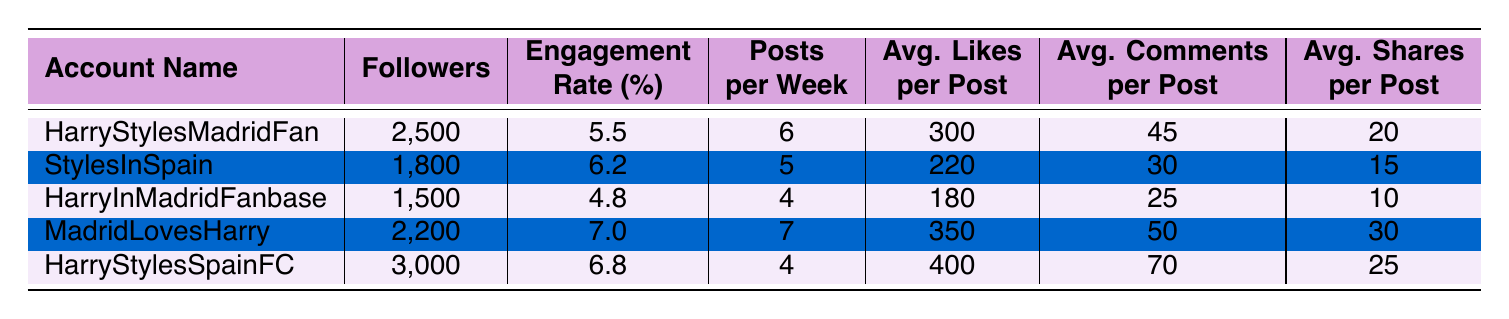What is the account with the highest followers? By comparing the followers column for all accounts, "HarryStylesSpainFC" has 3,000 followers, which is the highest among the listed accounts.
Answer: HarryStylesSpainFC What is the average engagement rate of the fan accounts? We calculate the average engagement rate by summing all engagement rates: (5.5 + 6.2 + 4.8 + 7.0 + 6.8) = 30.3. Then, divide by the number of accounts: 30.3 / 5 = 6.06.
Answer: 6.06 Does "MadridLovesHarry" have more average likes per post than "StylesInSpain"? "MadridLovesHarry" has 350 average likes per post while "StylesInSpain" has 220. Since 350 is greater than 220, the statement is true.
Answer: Yes Which account has the most shares per post? Reviewing the shares per post column, "MadridLovesHarry" has 30 shares per post, which is more than any other account.
Answer: MadridLovesHarry If we combine the followers of "HarryStylesMadridFan" and "HarryInMadridFanbase", how many total followers do we have? Adding the followers from both accounts: 2,500 (HarryStylesMadridFan) + 1,500 (HarryInMadridFanbase) = 4,000.
Answer: 4,000 What is the engagement rate of "HarryInMadridFanbase"? According to the table, "HarryInMadridFanbase" has an engagement rate of 4.8%.
Answer: 4.8 Is "HarryStylesSpainFC" the only account with an engagement rate above 6%? Checking the engagement rates, both "StylesInSpain" (6.2) and "HarryStylesSpainFC" (6.8) have engagement rates above 6%, so the statement is false.
Answer: No Which account has the highest average comments per post? Upon examining the average comments per post, "HarryStylesSpainFC" has 70, the highest among all accounts listed.
Answer: HarryStylesSpainFC 